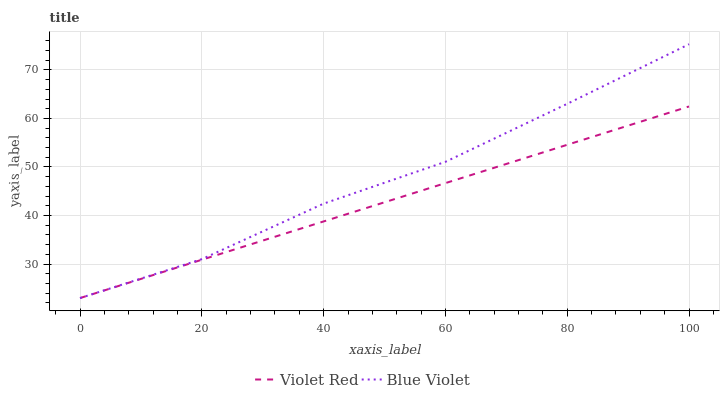Does Blue Violet have the minimum area under the curve?
Answer yes or no. No. Is Blue Violet the smoothest?
Answer yes or no. No. 